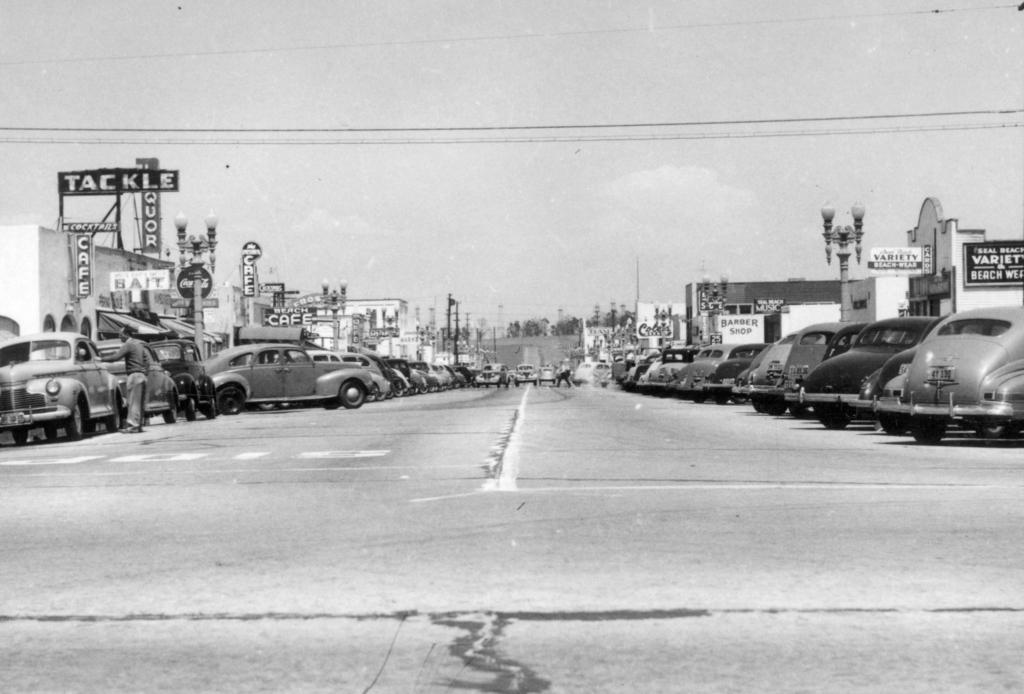What type of vehicles can be seen in the image? There are cars in the image. What structures are present in the image? There are buildings in the image. What are the boards associated with the buildings used for? The purpose of the boards associated with the buildings is not specified in the facts provided. What type of spoon can be seen in the image? There is no spoon present in the image. What type of stone is visible in the image? There is no stone present in the image. 